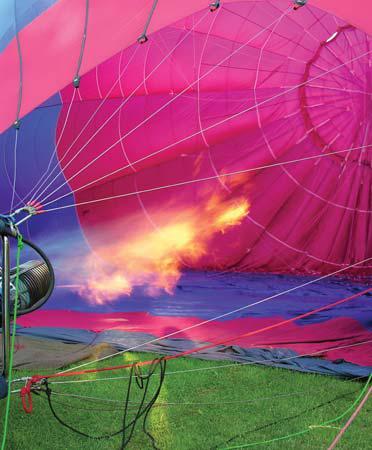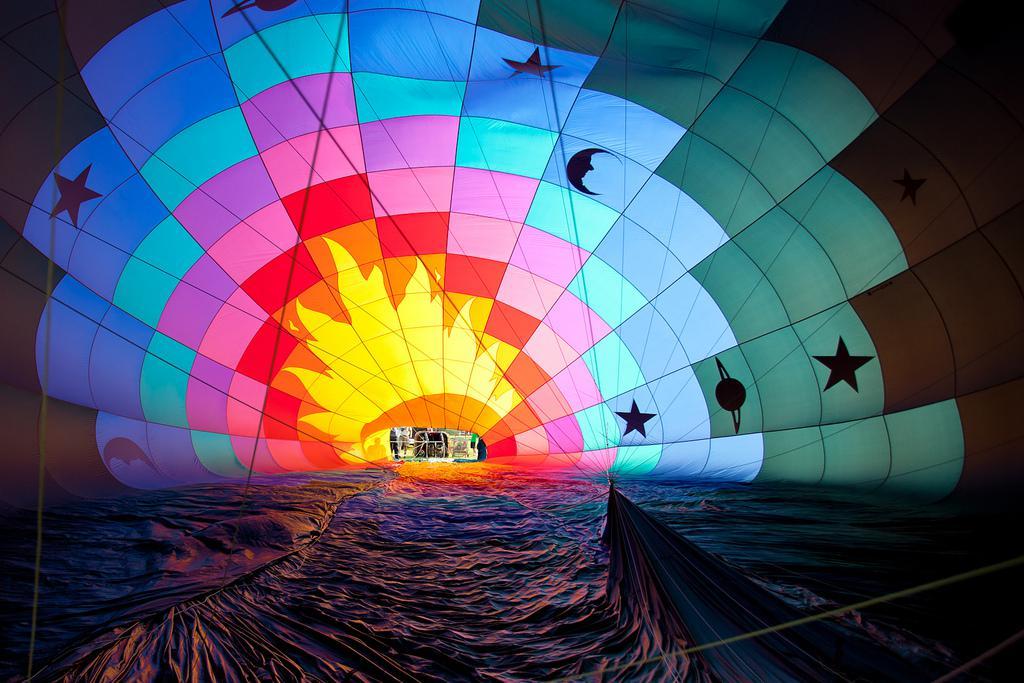The first image is the image on the left, the second image is the image on the right. For the images displayed, is the sentence "There is a person in one of the images" factually correct? Answer yes or no. No. The first image is the image on the left, the second image is the image on the right. Analyze the images presented: Is the assertion "The parachute in the right image contains at least four colors." valid? Answer yes or no. Yes. 